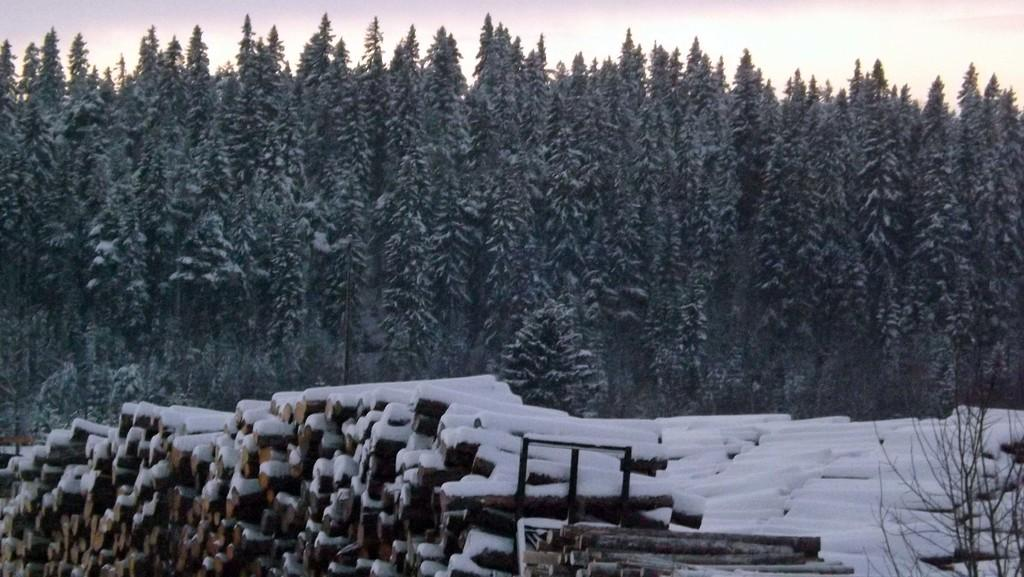What type of material is used for the objects in the image? The objects in the image are made of wood. How are the wooden objects affected by the weather in the image? The wooden objects are covered with snow. What can be seen in the background of the image? There are trees in the background of the image. What is visible at the top of the image? The sky is visible at the top of the image. What page of the book is the authority reading in the image? There is no book or authority figure present in the image; it features wooden objects covered with snow and a background with trees. 